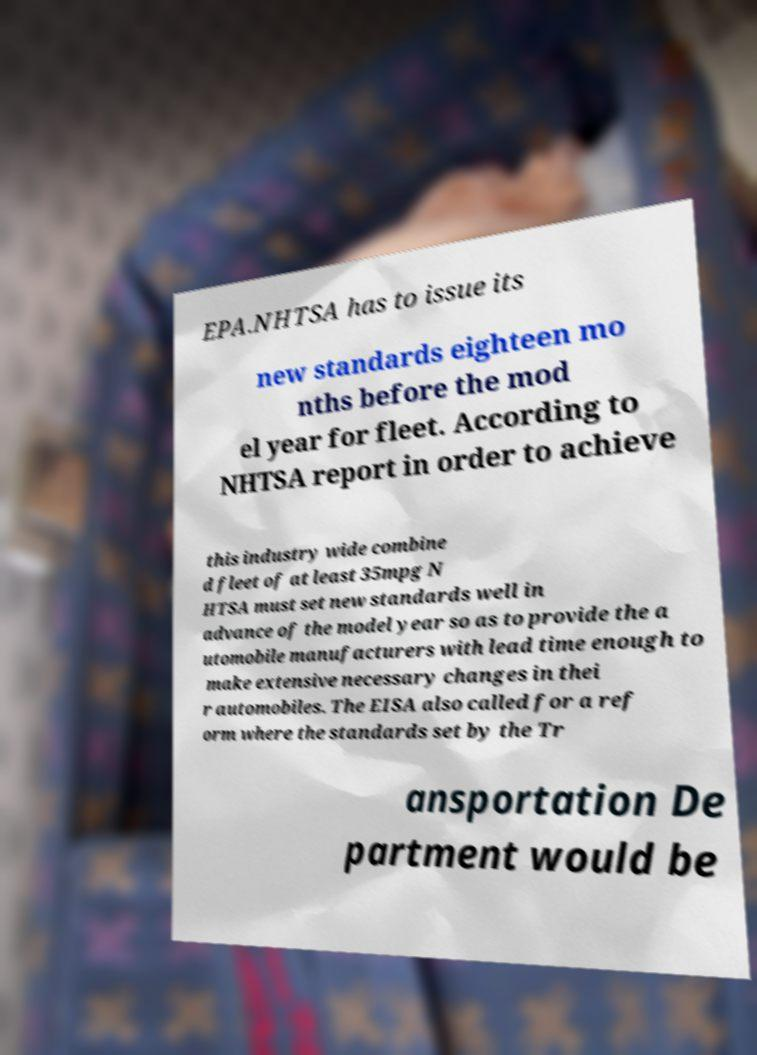For documentation purposes, I need the text within this image transcribed. Could you provide that? EPA.NHTSA has to issue its new standards eighteen mo nths before the mod el year for fleet. According to NHTSA report in order to achieve this industry wide combine d fleet of at least 35mpg N HTSA must set new standards well in advance of the model year so as to provide the a utomobile manufacturers with lead time enough to make extensive necessary changes in thei r automobiles. The EISA also called for a ref orm where the standards set by the Tr ansportation De partment would be 